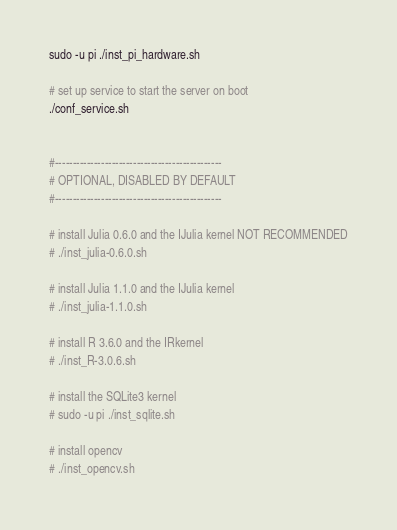Convert code to text. <code><loc_0><loc_0><loc_500><loc_500><_Bash_>sudo -u pi ./inst_pi_hardware.sh

# set up service to start the server on boot
./conf_service.sh


#-----------------------------------------------
# OPTIONAL, DISABLED BY DEFAULT
#-----------------------------------------------

# install Julia 0.6.0 and the IJulia kernel NOT RECOMMENDED
# ./inst_julia-0.6.0.sh

# install Julia 1.1.0 and the IJulia kernel
# ./inst_julia-1.1.0.sh

# install R 3.6.0 and the IRkernel
# ./inst_R-3.0.6.sh

# install the SQLite3 kernel
# sudo -u pi ./inst_sqlite.sh

# install opencv
# ./inst_opencv.sh
</code> 